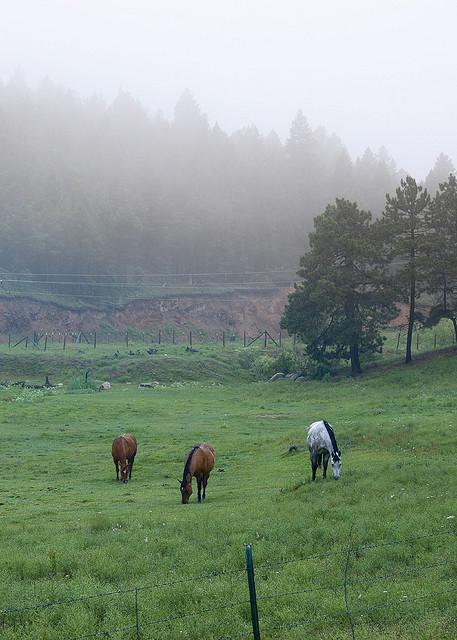Are all of the animals eating?
Keep it brief. Yes. Which animals are these?
Keep it brief. Horses. What animal is this?
Write a very short answer. Horse. How many animals are there?
Answer briefly. 3. Is this a sheep farm?
Concise answer only. No. Is there flowers out of focus?
Write a very short answer. No. What is the wall constructed of?
Quick response, please. Wire. What color is the horse that is different than the others?
Quick response, please. White. What animals are there?
Give a very brief answer. Horses. How many brown horses are there?
Quick response, please. 2. How many trees are not in the fog?
Short answer required. 3. How many animals are in the image?
Write a very short answer. 3. Is it a beautiful day?
Answer briefly. No. Where are the sheep?
Write a very short answer. In field. 